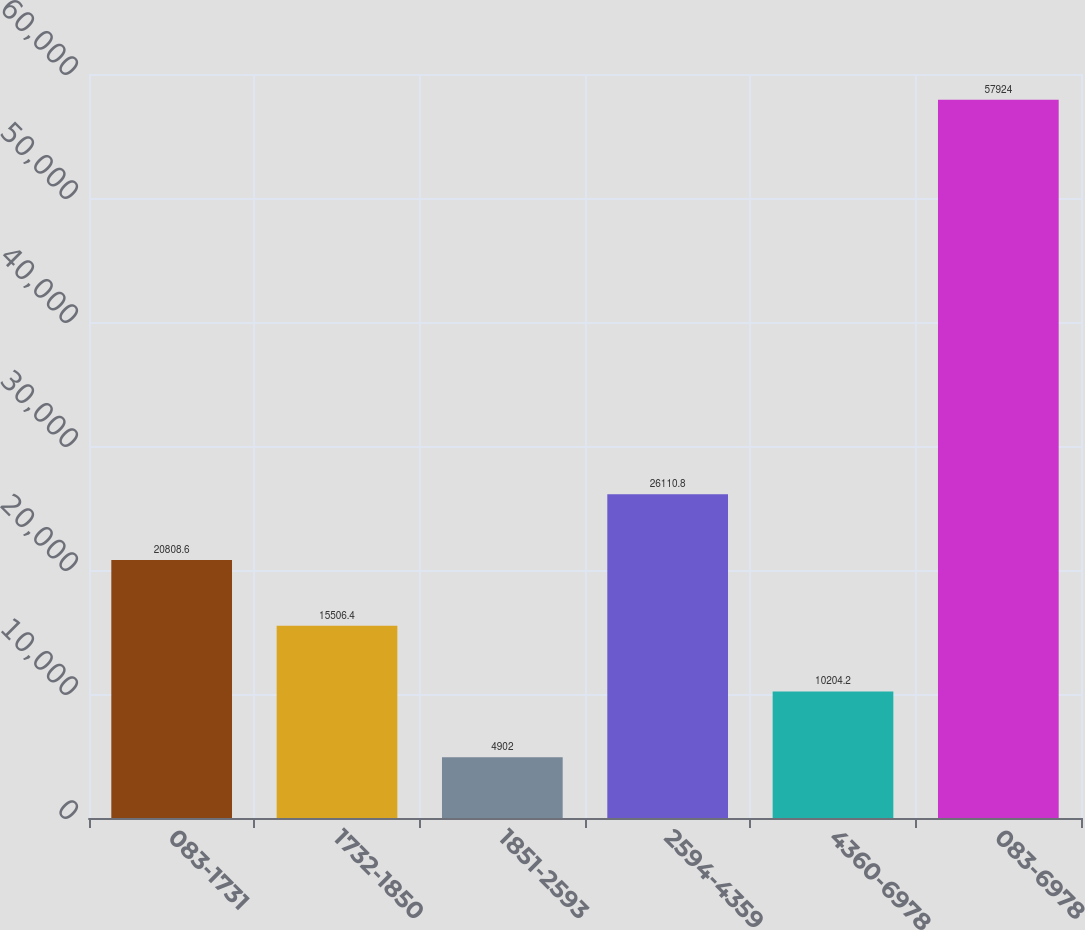<chart> <loc_0><loc_0><loc_500><loc_500><bar_chart><fcel>083-1731<fcel>1732-1850<fcel>1851-2593<fcel>2594-4359<fcel>4360-6978<fcel>083-6978<nl><fcel>20808.6<fcel>15506.4<fcel>4902<fcel>26110.8<fcel>10204.2<fcel>57924<nl></chart> 